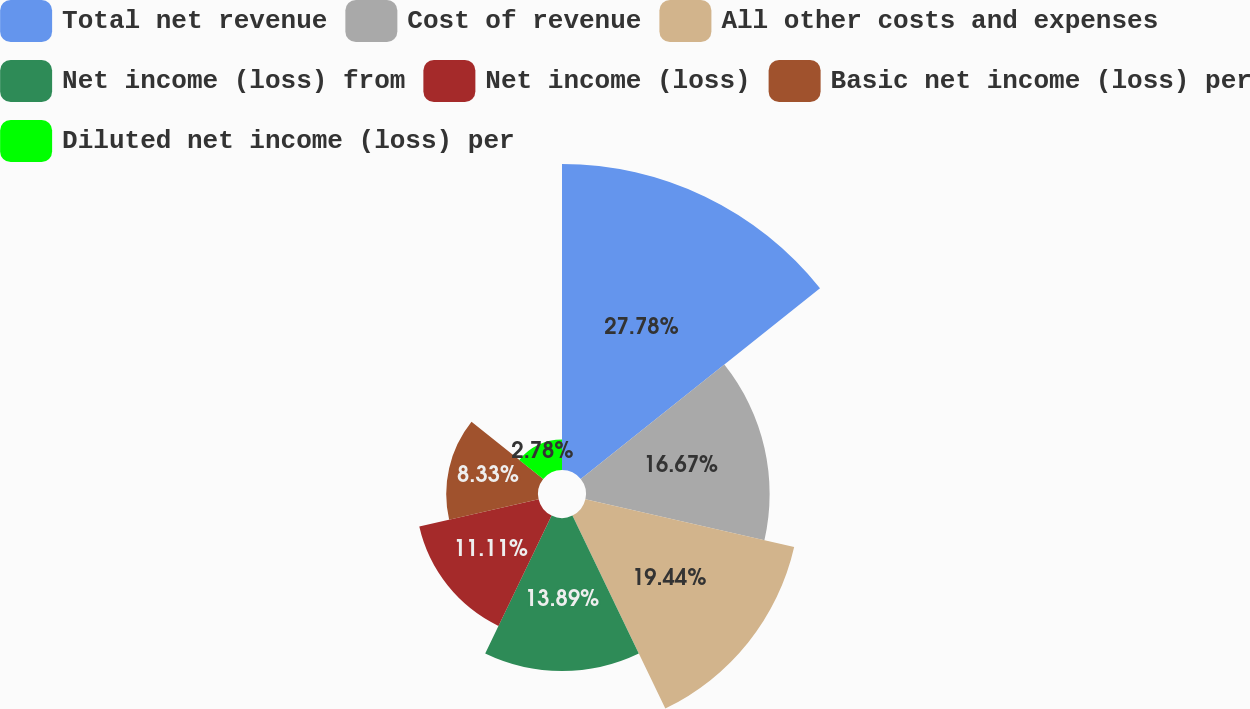Convert chart to OTSL. <chart><loc_0><loc_0><loc_500><loc_500><pie_chart><fcel>Total net revenue<fcel>Cost of revenue<fcel>All other costs and expenses<fcel>Net income (loss) from<fcel>Net income (loss)<fcel>Basic net income (loss) per<fcel>Diluted net income (loss) per<nl><fcel>27.78%<fcel>16.67%<fcel>19.44%<fcel>13.89%<fcel>11.11%<fcel>8.33%<fcel>2.78%<nl></chart> 